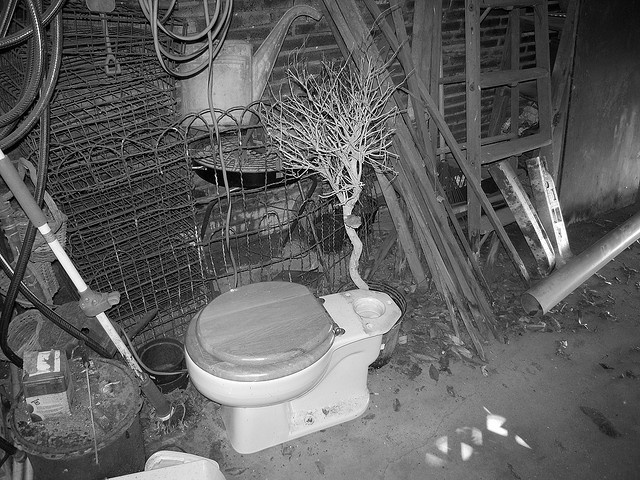Describe the objects in this image and their specific colors. I can see toilet in black, darkgray, lightgray, and gray tones and potted plant in black, gray, darkgray, and lightgray tones in this image. 